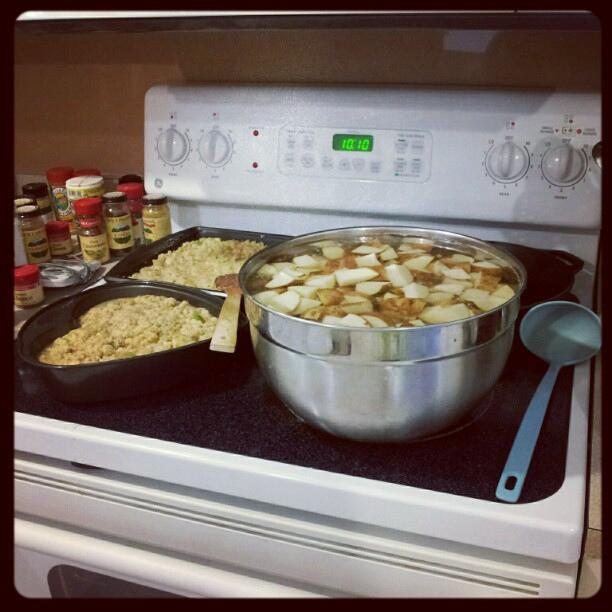Storing the items in the water prevents them from what?

Choices:
A) changing color
B) gathering bacteria
C) harboring flies
D) losing flavor changing color 